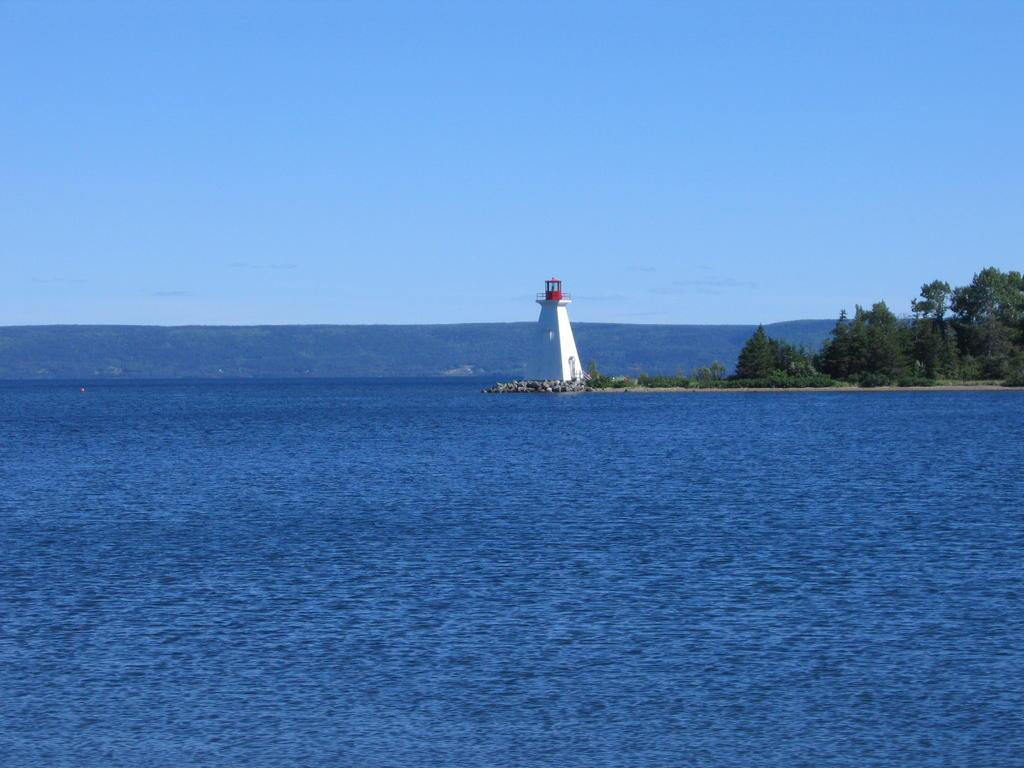What is the main feature of the image? There is water in the image. What is the color of the sky in the image? The sky is blue in the image. What type of structure can be seen in the image? There is a tower in the image. What type of vegetation is present in the image? There are trees in the image. What type of pipe can be seen in the image? There is no pipe present in the image. What religious symbol can be seen in the image? There is no religious symbol present in the image. 